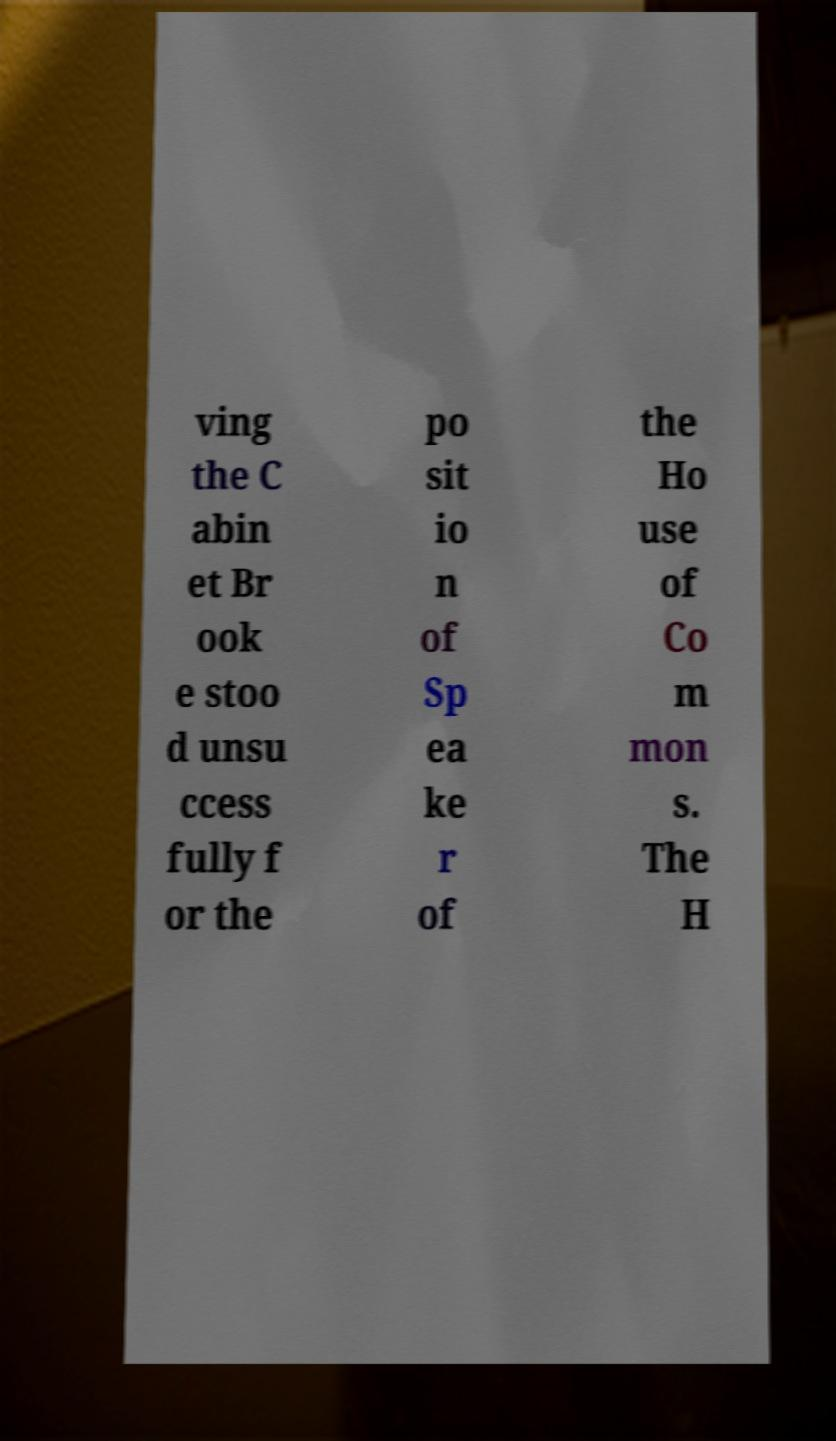Could you extract and type out the text from this image? ving the C abin et Br ook e stoo d unsu ccess fully f or the po sit io n of Sp ea ke r of the Ho use of Co m mon s. The H 